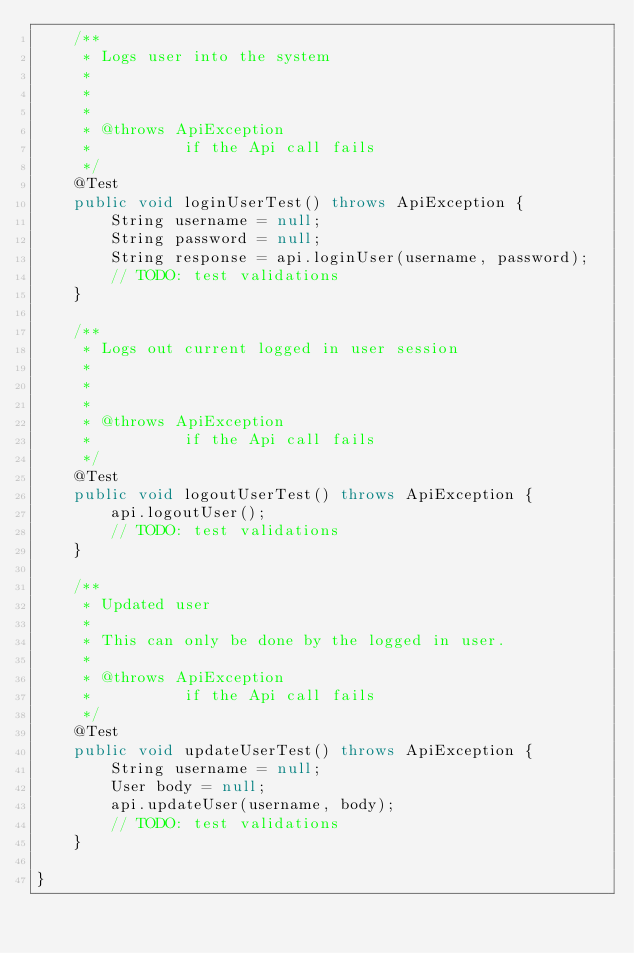<code> <loc_0><loc_0><loc_500><loc_500><_Java_>    /**
     * Logs user into the system
     *
     * 
     *
     * @throws ApiException
     *          if the Api call fails
     */
    @Test
    public void loginUserTest() throws ApiException {
        String username = null;
        String password = null;
        String response = api.loginUser(username, password);
        // TODO: test validations
    }
    
    /**
     * Logs out current logged in user session
     *
     * 
     *
     * @throws ApiException
     *          if the Api call fails
     */
    @Test
    public void logoutUserTest() throws ApiException {
        api.logoutUser();
        // TODO: test validations
    }
    
    /**
     * Updated user
     *
     * This can only be done by the logged in user.
     *
     * @throws ApiException
     *          if the Api call fails
     */
    @Test
    public void updateUserTest() throws ApiException {
        String username = null;
        User body = null;
        api.updateUser(username, body);
        // TODO: test validations
    }
    
}
</code> 